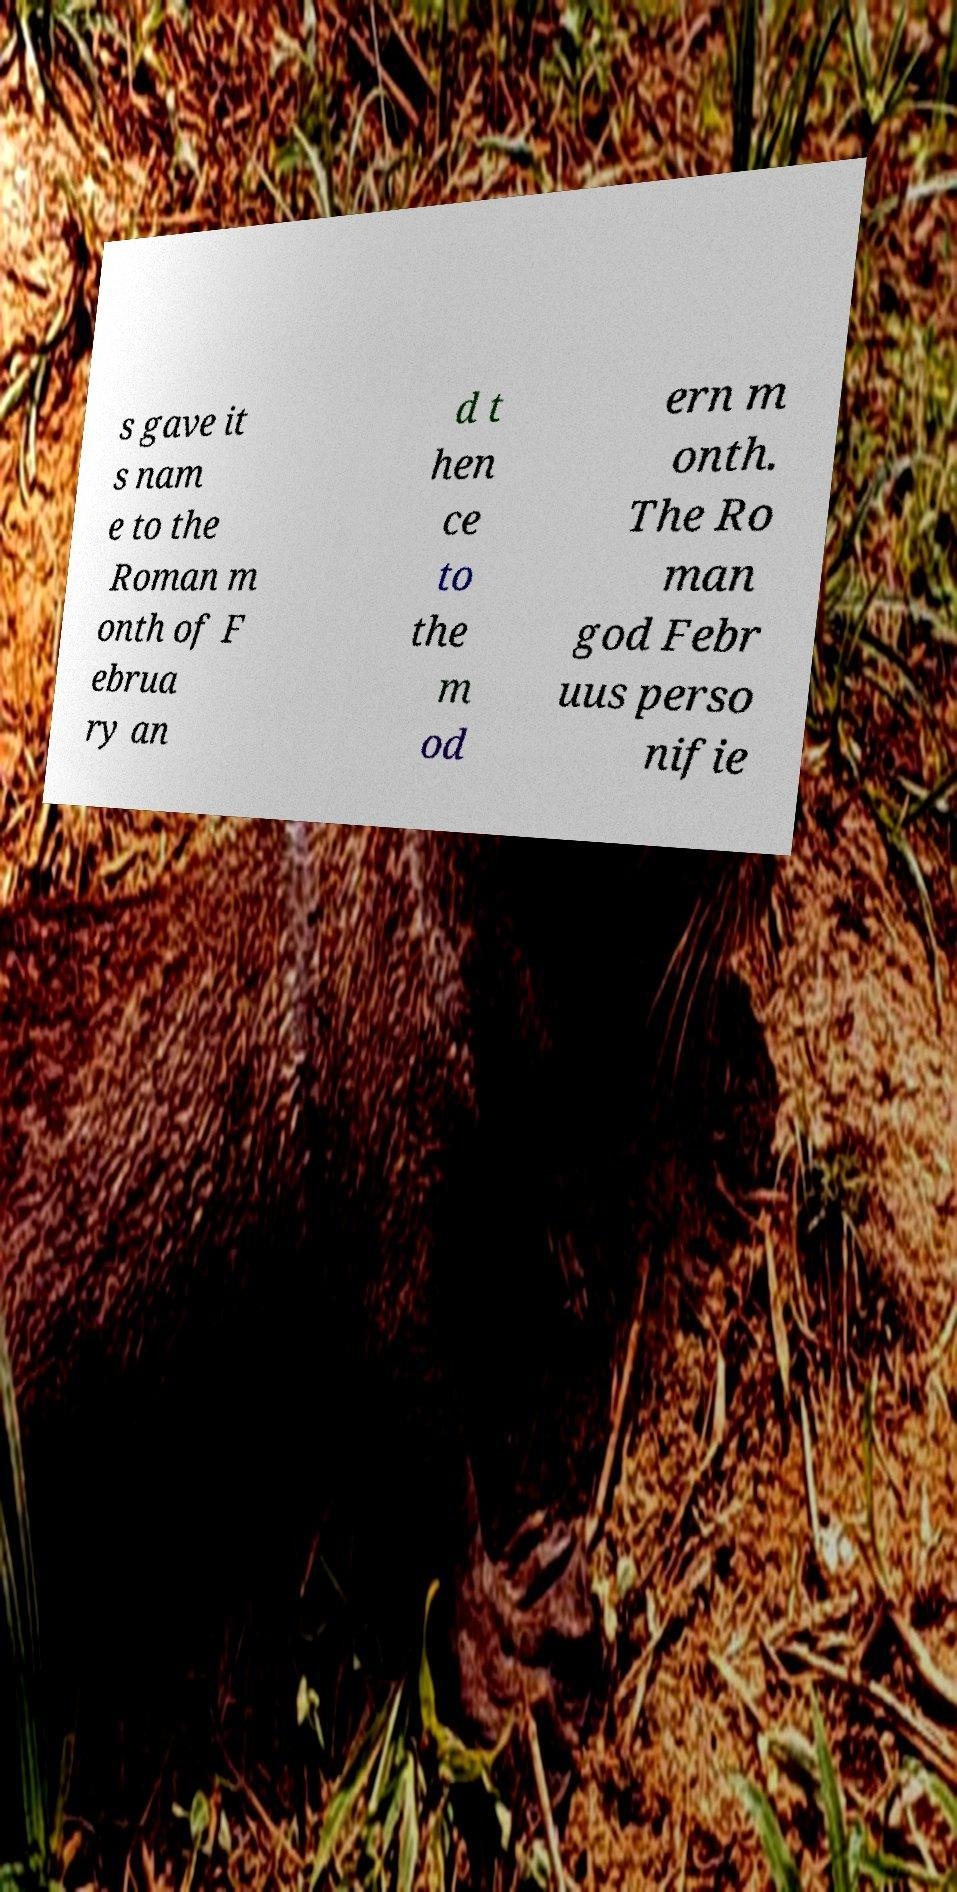Can you accurately transcribe the text from the provided image for me? s gave it s nam e to the Roman m onth of F ebrua ry an d t hen ce to the m od ern m onth. The Ro man god Febr uus perso nifie 